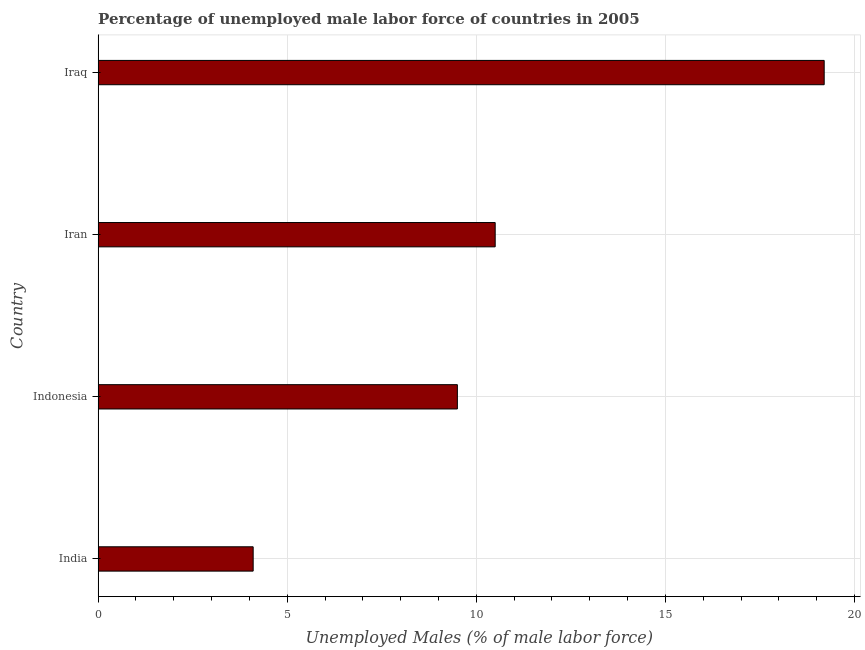What is the title of the graph?
Your answer should be compact. Percentage of unemployed male labor force of countries in 2005. What is the label or title of the X-axis?
Your response must be concise. Unemployed Males (% of male labor force). What is the total unemployed male labour force in Iran?
Provide a short and direct response. 10.5. Across all countries, what is the maximum total unemployed male labour force?
Your response must be concise. 19.2. Across all countries, what is the minimum total unemployed male labour force?
Make the answer very short. 4.1. In which country was the total unemployed male labour force maximum?
Offer a terse response. Iraq. What is the sum of the total unemployed male labour force?
Your response must be concise. 43.3. What is the average total unemployed male labour force per country?
Make the answer very short. 10.82. In how many countries, is the total unemployed male labour force greater than 16 %?
Offer a very short reply. 1. What is the ratio of the total unemployed male labour force in India to that in Iraq?
Provide a succinct answer. 0.21. Is the total unemployed male labour force in Iran less than that in Iraq?
Offer a very short reply. Yes. Is the difference between the total unemployed male labour force in India and Iraq greater than the difference between any two countries?
Make the answer very short. Yes. What is the difference between the highest and the lowest total unemployed male labour force?
Make the answer very short. 15.1. Are all the bars in the graph horizontal?
Offer a terse response. Yes. What is the difference between two consecutive major ticks on the X-axis?
Provide a short and direct response. 5. Are the values on the major ticks of X-axis written in scientific E-notation?
Your answer should be compact. No. What is the Unemployed Males (% of male labor force) in India?
Provide a short and direct response. 4.1. What is the Unemployed Males (% of male labor force) of Indonesia?
Your answer should be compact. 9.5. What is the Unemployed Males (% of male labor force) of Iran?
Your answer should be very brief. 10.5. What is the Unemployed Males (% of male labor force) of Iraq?
Make the answer very short. 19.2. What is the difference between the Unemployed Males (% of male labor force) in India and Indonesia?
Keep it short and to the point. -5.4. What is the difference between the Unemployed Males (% of male labor force) in India and Iran?
Offer a terse response. -6.4. What is the difference between the Unemployed Males (% of male labor force) in India and Iraq?
Provide a succinct answer. -15.1. What is the difference between the Unemployed Males (% of male labor force) in Indonesia and Iran?
Your answer should be very brief. -1. What is the difference between the Unemployed Males (% of male labor force) in Indonesia and Iraq?
Your response must be concise. -9.7. What is the difference between the Unemployed Males (% of male labor force) in Iran and Iraq?
Your response must be concise. -8.7. What is the ratio of the Unemployed Males (% of male labor force) in India to that in Indonesia?
Offer a very short reply. 0.43. What is the ratio of the Unemployed Males (% of male labor force) in India to that in Iran?
Your answer should be very brief. 0.39. What is the ratio of the Unemployed Males (% of male labor force) in India to that in Iraq?
Your answer should be very brief. 0.21. What is the ratio of the Unemployed Males (% of male labor force) in Indonesia to that in Iran?
Keep it short and to the point. 0.91. What is the ratio of the Unemployed Males (% of male labor force) in Indonesia to that in Iraq?
Your answer should be very brief. 0.49. What is the ratio of the Unemployed Males (% of male labor force) in Iran to that in Iraq?
Give a very brief answer. 0.55. 